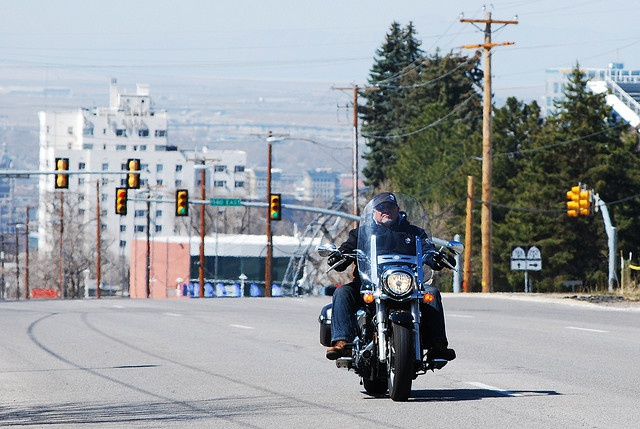Describe the objects in this image and their specific colors. I can see motorcycle in lightgray, black, gray, and navy tones, people in lightgray, black, navy, blue, and gray tones, traffic light in lightgray, brown, orange, and gold tones, traffic light in lightgray, black, brown, khaki, and gray tones, and traffic light in lightgray, black, khaki, brown, and gold tones in this image. 